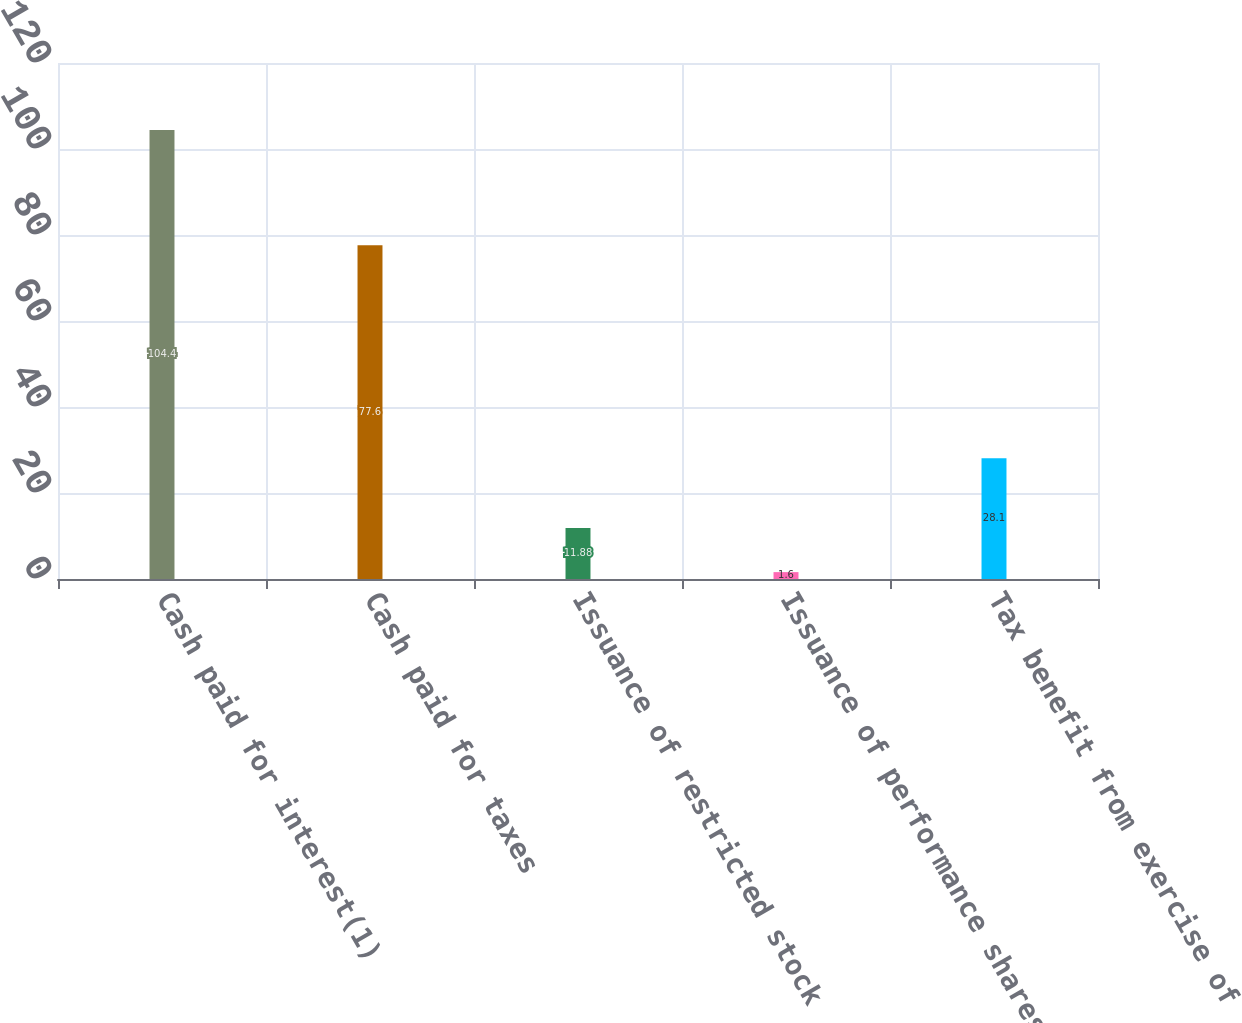<chart> <loc_0><loc_0><loc_500><loc_500><bar_chart><fcel>Cash paid for interest(1)<fcel>Cash paid for taxes<fcel>Issuance of restricted stock<fcel>Issuance of performance shares<fcel>Tax benefit from exercise of<nl><fcel>104.4<fcel>77.6<fcel>11.88<fcel>1.6<fcel>28.1<nl></chart> 